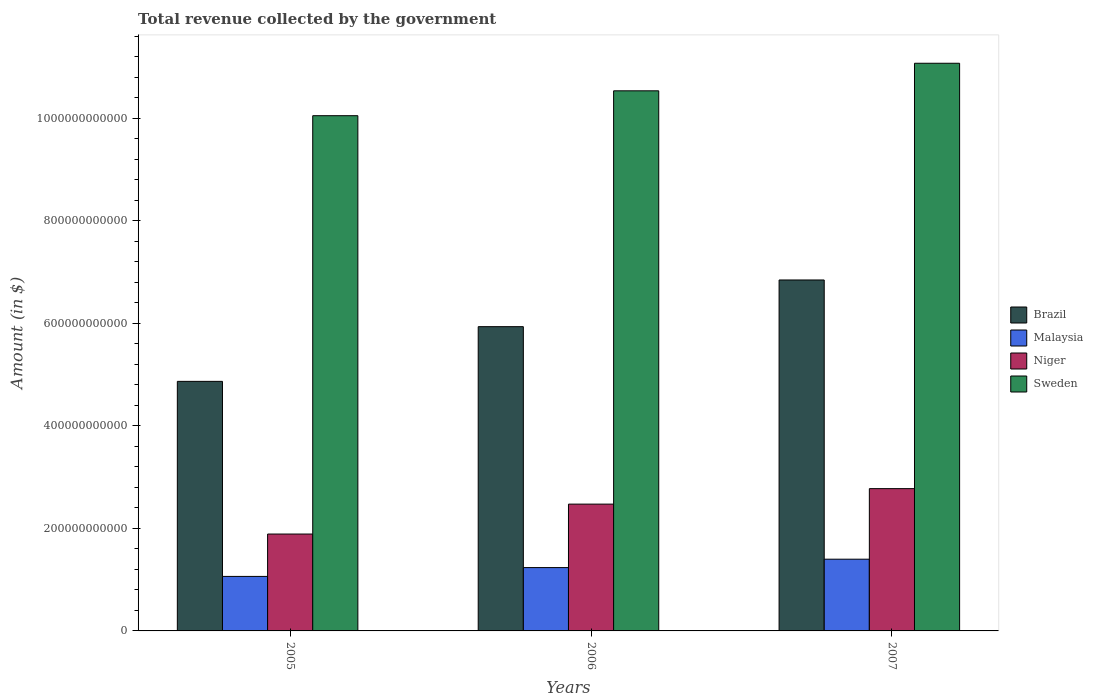How many different coloured bars are there?
Offer a very short reply. 4. How many bars are there on the 1st tick from the right?
Your answer should be very brief. 4. What is the total revenue collected by the government in Brazil in 2005?
Provide a short and direct response. 4.87e+11. Across all years, what is the maximum total revenue collected by the government in Sweden?
Keep it short and to the point. 1.11e+12. Across all years, what is the minimum total revenue collected by the government in Brazil?
Provide a succinct answer. 4.87e+11. In which year was the total revenue collected by the government in Brazil maximum?
Your answer should be compact. 2007. What is the total total revenue collected by the government in Niger in the graph?
Your response must be concise. 7.14e+11. What is the difference between the total revenue collected by the government in Sweden in 2005 and that in 2006?
Offer a very short reply. -4.85e+1. What is the difference between the total revenue collected by the government in Sweden in 2007 and the total revenue collected by the government in Niger in 2005?
Your response must be concise. 9.18e+11. What is the average total revenue collected by the government in Sweden per year?
Give a very brief answer. 1.06e+12. In the year 2006, what is the difference between the total revenue collected by the government in Niger and total revenue collected by the government in Brazil?
Give a very brief answer. -3.46e+11. What is the ratio of the total revenue collected by the government in Brazil in 2006 to that in 2007?
Offer a terse response. 0.87. Is the total revenue collected by the government in Niger in 2005 less than that in 2006?
Offer a terse response. Yes. Is the difference between the total revenue collected by the government in Niger in 2005 and 2007 greater than the difference between the total revenue collected by the government in Brazil in 2005 and 2007?
Ensure brevity in your answer.  Yes. What is the difference between the highest and the second highest total revenue collected by the government in Sweden?
Your answer should be very brief. 5.37e+1. What is the difference between the highest and the lowest total revenue collected by the government in Sweden?
Your answer should be very brief. 1.02e+11. In how many years, is the total revenue collected by the government in Niger greater than the average total revenue collected by the government in Niger taken over all years?
Your response must be concise. 2. Is it the case that in every year, the sum of the total revenue collected by the government in Brazil and total revenue collected by the government in Malaysia is greater than the sum of total revenue collected by the government in Sweden and total revenue collected by the government in Niger?
Keep it short and to the point. No. What does the 2nd bar from the right in 2007 represents?
Keep it short and to the point. Niger. Are all the bars in the graph horizontal?
Provide a succinct answer. No. How many years are there in the graph?
Your answer should be very brief. 3. What is the difference between two consecutive major ticks on the Y-axis?
Your answer should be compact. 2.00e+11. Does the graph contain grids?
Offer a terse response. No. How many legend labels are there?
Your answer should be very brief. 4. What is the title of the graph?
Your answer should be very brief. Total revenue collected by the government. What is the label or title of the X-axis?
Your answer should be compact. Years. What is the label or title of the Y-axis?
Your answer should be very brief. Amount (in $). What is the Amount (in $) of Brazil in 2005?
Your response must be concise. 4.87e+11. What is the Amount (in $) of Malaysia in 2005?
Your answer should be compact. 1.06e+11. What is the Amount (in $) in Niger in 2005?
Your response must be concise. 1.89e+11. What is the Amount (in $) of Sweden in 2005?
Make the answer very short. 1.00e+12. What is the Amount (in $) in Brazil in 2006?
Keep it short and to the point. 5.93e+11. What is the Amount (in $) of Malaysia in 2006?
Your answer should be very brief. 1.24e+11. What is the Amount (in $) in Niger in 2006?
Provide a succinct answer. 2.47e+11. What is the Amount (in $) of Sweden in 2006?
Provide a succinct answer. 1.05e+12. What is the Amount (in $) of Brazil in 2007?
Keep it short and to the point. 6.85e+11. What is the Amount (in $) in Malaysia in 2007?
Ensure brevity in your answer.  1.40e+11. What is the Amount (in $) of Niger in 2007?
Your response must be concise. 2.78e+11. What is the Amount (in $) in Sweden in 2007?
Your answer should be compact. 1.11e+12. Across all years, what is the maximum Amount (in $) of Brazil?
Provide a succinct answer. 6.85e+11. Across all years, what is the maximum Amount (in $) of Malaysia?
Provide a succinct answer. 1.40e+11. Across all years, what is the maximum Amount (in $) of Niger?
Keep it short and to the point. 2.78e+11. Across all years, what is the maximum Amount (in $) of Sweden?
Make the answer very short. 1.11e+12. Across all years, what is the minimum Amount (in $) in Brazil?
Offer a very short reply. 4.87e+11. Across all years, what is the minimum Amount (in $) of Malaysia?
Provide a succinct answer. 1.06e+11. Across all years, what is the minimum Amount (in $) in Niger?
Make the answer very short. 1.89e+11. Across all years, what is the minimum Amount (in $) of Sweden?
Your response must be concise. 1.00e+12. What is the total Amount (in $) in Brazil in the graph?
Provide a succinct answer. 1.76e+12. What is the total Amount (in $) in Malaysia in the graph?
Provide a short and direct response. 3.70e+11. What is the total Amount (in $) of Niger in the graph?
Keep it short and to the point. 7.14e+11. What is the total Amount (in $) of Sweden in the graph?
Give a very brief answer. 3.17e+12. What is the difference between the Amount (in $) in Brazil in 2005 and that in 2006?
Provide a short and direct response. -1.07e+11. What is the difference between the Amount (in $) in Malaysia in 2005 and that in 2006?
Offer a very short reply. -1.72e+1. What is the difference between the Amount (in $) of Niger in 2005 and that in 2006?
Make the answer very short. -5.83e+1. What is the difference between the Amount (in $) in Sweden in 2005 and that in 2006?
Make the answer very short. -4.85e+1. What is the difference between the Amount (in $) in Brazil in 2005 and that in 2007?
Your response must be concise. -1.98e+11. What is the difference between the Amount (in $) in Malaysia in 2005 and that in 2007?
Provide a succinct answer. -3.36e+1. What is the difference between the Amount (in $) in Niger in 2005 and that in 2007?
Your response must be concise. -8.85e+1. What is the difference between the Amount (in $) in Sweden in 2005 and that in 2007?
Provide a short and direct response. -1.02e+11. What is the difference between the Amount (in $) of Brazil in 2006 and that in 2007?
Offer a terse response. -9.11e+1. What is the difference between the Amount (in $) in Malaysia in 2006 and that in 2007?
Your response must be concise. -1.63e+1. What is the difference between the Amount (in $) of Niger in 2006 and that in 2007?
Your response must be concise. -3.02e+1. What is the difference between the Amount (in $) of Sweden in 2006 and that in 2007?
Provide a succinct answer. -5.37e+1. What is the difference between the Amount (in $) in Brazil in 2005 and the Amount (in $) in Malaysia in 2006?
Provide a succinct answer. 3.63e+11. What is the difference between the Amount (in $) in Brazil in 2005 and the Amount (in $) in Niger in 2006?
Your answer should be very brief. 2.39e+11. What is the difference between the Amount (in $) in Brazil in 2005 and the Amount (in $) in Sweden in 2006?
Your answer should be very brief. -5.67e+11. What is the difference between the Amount (in $) of Malaysia in 2005 and the Amount (in $) of Niger in 2006?
Your answer should be compact. -1.41e+11. What is the difference between the Amount (in $) of Malaysia in 2005 and the Amount (in $) of Sweden in 2006?
Offer a very short reply. -9.47e+11. What is the difference between the Amount (in $) in Niger in 2005 and the Amount (in $) in Sweden in 2006?
Provide a short and direct response. -8.64e+11. What is the difference between the Amount (in $) of Brazil in 2005 and the Amount (in $) of Malaysia in 2007?
Offer a terse response. 3.47e+11. What is the difference between the Amount (in $) of Brazil in 2005 and the Amount (in $) of Niger in 2007?
Keep it short and to the point. 2.09e+11. What is the difference between the Amount (in $) in Brazil in 2005 and the Amount (in $) in Sweden in 2007?
Give a very brief answer. -6.20e+11. What is the difference between the Amount (in $) of Malaysia in 2005 and the Amount (in $) of Niger in 2007?
Give a very brief answer. -1.71e+11. What is the difference between the Amount (in $) in Malaysia in 2005 and the Amount (in $) in Sweden in 2007?
Offer a very short reply. -1.00e+12. What is the difference between the Amount (in $) in Niger in 2005 and the Amount (in $) in Sweden in 2007?
Offer a terse response. -9.18e+11. What is the difference between the Amount (in $) in Brazil in 2006 and the Amount (in $) in Malaysia in 2007?
Offer a very short reply. 4.54e+11. What is the difference between the Amount (in $) of Brazil in 2006 and the Amount (in $) of Niger in 2007?
Your response must be concise. 3.16e+11. What is the difference between the Amount (in $) of Brazil in 2006 and the Amount (in $) of Sweden in 2007?
Offer a terse response. -5.14e+11. What is the difference between the Amount (in $) in Malaysia in 2006 and the Amount (in $) in Niger in 2007?
Offer a very short reply. -1.54e+11. What is the difference between the Amount (in $) of Malaysia in 2006 and the Amount (in $) of Sweden in 2007?
Provide a short and direct response. -9.84e+11. What is the difference between the Amount (in $) in Niger in 2006 and the Amount (in $) in Sweden in 2007?
Your answer should be very brief. -8.60e+11. What is the average Amount (in $) in Brazil per year?
Ensure brevity in your answer.  5.88e+11. What is the average Amount (in $) of Malaysia per year?
Make the answer very short. 1.23e+11. What is the average Amount (in $) of Niger per year?
Offer a terse response. 2.38e+11. What is the average Amount (in $) of Sweden per year?
Give a very brief answer. 1.06e+12. In the year 2005, what is the difference between the Amount (in $) of Brazil and Amount (in $) of Malaysia?
Your response must be concise. 3.80e+11. In the year 2005, what is the difference between the Amount (in $) in Brazil and Amount (in $) in Niger?
Your response must be concise. 2.98e+11. In the year 2005, what is the difference between the Amount (in $) of Brazil and Amount (in $) of Sweden?
Ensure brevity in your answer.  -5.18e+11. In the year 2005, what is the difference between the Amount (in $) of Malaysia and Amount (in $) of Niger?
Your response must be concise. -8.27e+1. In the year 2005, what is the difference between the Amount (in $) in Malaysia and Amount (in $) in Sweden?
Your answer should be very brief. -8.99e+11. In the year 2005, what is the difference between the Amount (in $) of Niger and Amount (in $) of Sweden?
Your response must be concise. -8.16e+11. In the year 2006, what is the difference between the Amount (in $) in Brazil and Amount (in $) in Malaysia?
Provide a succinct answer. 4.70e+11. In the year 2006, what is the difference between the Amount (in $) in Brazil and Amount (in $) in Niger?
Ensure brevity in your answer.  3.46e+11. In the year 2006, what is the difference between the Amount (in $) in Brazil and Amount (in $) in Sweden?
Give a very brief answer. -4.60e+11. In the year 2006, what is the difference between the Amount (in $) of Malaysia and Amount (in $) of Niger?
Your response must be concise. -1.24e+11. In the year 2006, what is the difference between the Amount (in $) of Malaysia and Amount (in $) of Sweden?
Keep it short and to the point. -9.30e+11. In the year 2006, what is the difference between the Amount (in $) of Niger and Amount (in $) of Sweden?
Give a very brief answer. -8.06e+11. In the year 2007, what is the difference between the Amount (in $) in Brazil and Amount (in $) in Malaysia?
Make the answer very short. 5.45e+11. In the year 2007, what is the difference between the Amount (in $) in Brazil and Amount (in $) in Niger?
Offer a very short reply. 4.07e+11. In the year 2007, what is the difference between the Amount (in $) of Brazil and Amount (in $) of Sweden?
Keep it short and to the point. -4.23e+11. In the year 2007, what is the difference between the Amount (in $) in Malaysia and Amount (in $) in Niger?
Make the answer very short. -1.38e+11. In the year 2007, what is the difference between the Amount (in $) of Malaysia and Amount (in $) of Sweden?
Provide a succinct answer. -9.67e+11. In the year 2007, what is the difference between the Amount (in $) in Niger and Amount (in $) in Sweden?
Give a very brief answer. -8.30e+11. What is the ratio of the Amount (in $) in Brazil in 2005 to that in 2006?
Ensure brevity in your answer.  0.82. What is the ratio of the Amount (in $) of Malaysia in 2005 to that in 2006?
Offer a terse response. 0.86. What is the ratio of the Amount (in $) in Niger in 2005 to that in 2006?
Offer a very short reply. 0.76. What is the ratio of the Amount (in $) of Sweden in 2005 to that in 2006?
Give a very brief answer. 0.95. What is the ratio of the Amount (in $) of Brazil in 2005 to that in 2007?
Your answer should be very brief. 0.71. What is the ratio of the Amount (in $) in Malaysia in 2005 to that in 2007?
Keep it short and to the point. 0.76. What is the ratio of the Amount (in $) in Niger in 2005 to that in 2007?
Your response must be concise. 0.68. What is the ratio of the Amount (in $) in Sweden in 2005 to that in 2007?
Your answer should be compact. 0.91. What is the ratio of the Amount (in $) of Brazil in 2006 to that in 2007?
Keep it short and to the point. 0.87. What is the ratio of the Amount (in $) of Malaysia in 2006 to that in 2007?
Provide a succinct answer. 0.88. What is the ratio of the Amount (in $) of Niger in 2006 to that in 2007?
Give a very brief answer. 0.89. What is the ratio of the Amount (in $) of Sweden in 2006 to that in 2007?
Offer a very short reply. 0.95. What is the difference between the highest and the second highest Amount (in $) in Brazil?
Provide a short and direct response. 9.11e+1. What is the difference between the highest and the second highest Amount (in $) in Malaysia?
Your response must be concise. 1.63e+1. What is the difference between the highest and the second highest Amount (in $) of Niger?
Your response must be concise. 3.02e+1. What is the difference between the highest and the second highest Amount (in $) of Sweden?
Your answer should be very brief. 5.37e+1. What is the difference between the highest and the lowest Amount (in $) of Brazil?
Provide a succinct answer. 1.98e+11. What is the difference between the highest and the lowest Amount (in $) of Malaysia?
Your response must be concise. 3.36e+1. What is the difference between the highest and the lowest Amount (in $) of Niger?
Ensure brevity in your answer.  8.85e+1. What is the difference between the highest and the lowest Amount (in $) of Sweden?
Offer a terse response. 1.02e+11. 